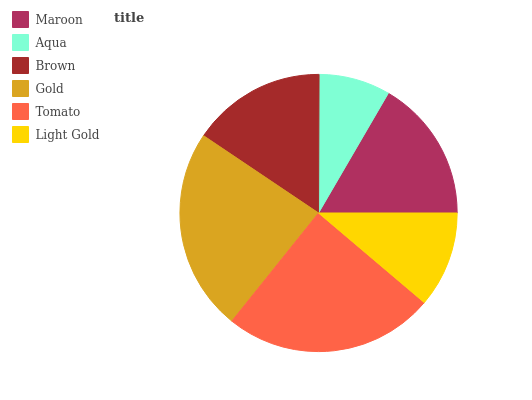Is Aqua the minimum?
Answer yes or no. Yes. Is Tomato the maximum?
Answer yes or no. Yes. Is Brown the minimum?
Answer yes or no. No. Is Brown the maximum?
Answer yes or no. No. Is Brown greater than Aqua?
Answer yes or no. Yes. Is Aqua less than Brown?
Answer yes or no. Yes. Is Aqua greater than Brown?
Answer yes or no. No. Is Brown less than Aqua?
Answer yes or no. No. Is Maroon the high median?
Answer yes or no. Yes. Is Brown the low median?
Answer yes or no. Yes. Is Light Gold the high median?
Answer yes or no. No. Is Tomato the low median?
Answer yes or no. No. 